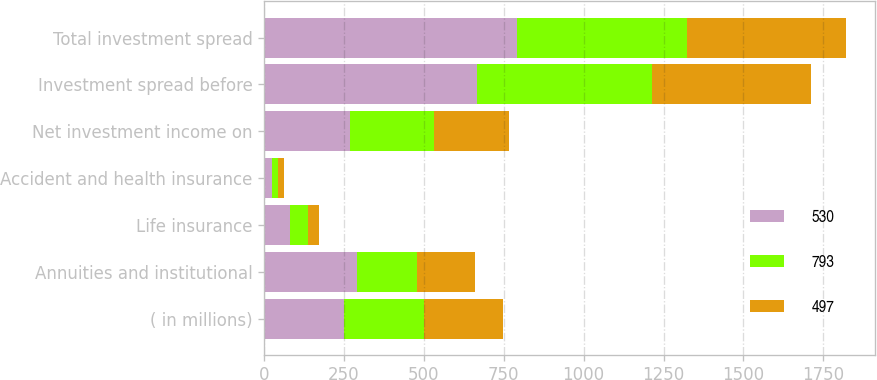Convert chart. <chart><loc_0><loc_0><loc_500><loc_500><stacked_bar_chart><ecel><fcel>( in millions)<fcel>Annuities and institutional<fcel>Life insurance<fcel>Accident and health insurance<fcel>Net investment income on<fcel>Investment spread before<fcel>Total investment spread<nl><fcel>530<fcel>249.5<fcel>292<fcel>82<fcel>25<fcel>268<fcel>667<fcel>793<nl><fcel>793<fcel>249.5<fcel>188<fcel>54<fcel>19<fcel>265<fcel>548<fcel>530<nl><fcel>497<fcel>249.5<fcel>179<fcel>35<fcel>18<fcel>234<fcel>497<fcel>497<nl></chart> 